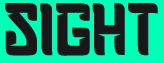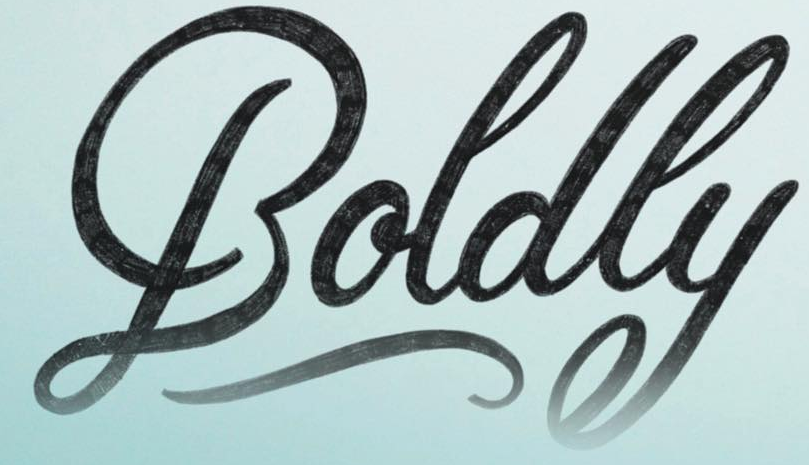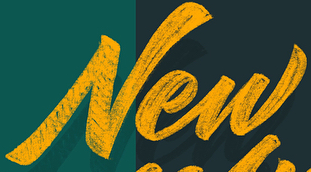What text is displayed in these images sequentially, separated by a semicolon? SIGHT; Boldly; New 